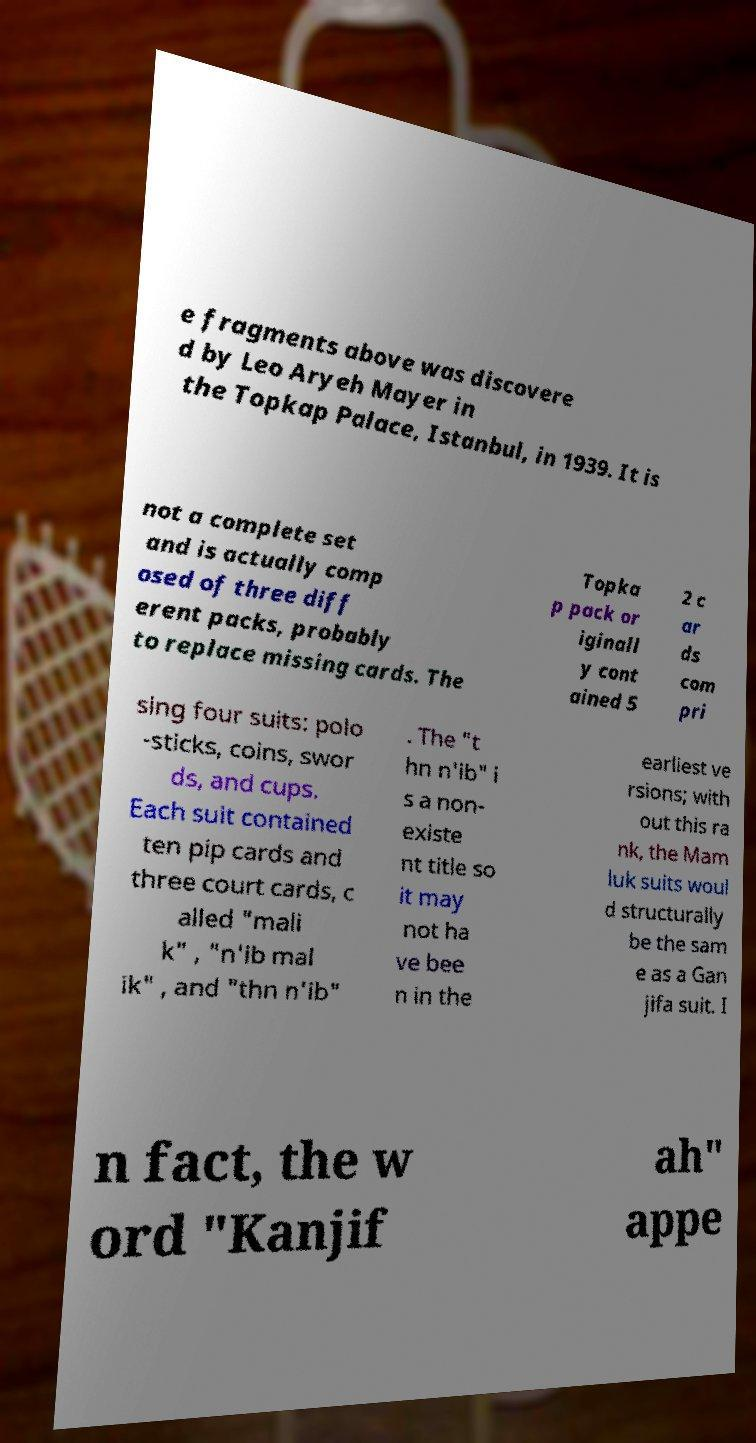Can you accurately transcribe the text from the provided image for me? e fragments above was discovere d by Leo Aryeh Mayer in the Topkap Palace, Istanbul, in 1939. It is not a complete set and is actually comp osed of three diff erent packs, probably to replace missing cards. The Topka p pack or iginall y cont ained 5 2 c ar ds com pri sing four suits: polo -sticks, coins, swor ds, and cups. Each suit contained ten pip cards and three court cards, c alled "mali k" , "n'ib mal ik" , and "thn n'ib" . The "t hn n'ib" i s a non- existe nt title so it may not ha ve bee n in the earliest ve rsions; with out this ra nk, the Mam luk suits woul d structurally be the sam e as a Gan jifa suit. I n fact, the w ord "Kanjif ah" appe 